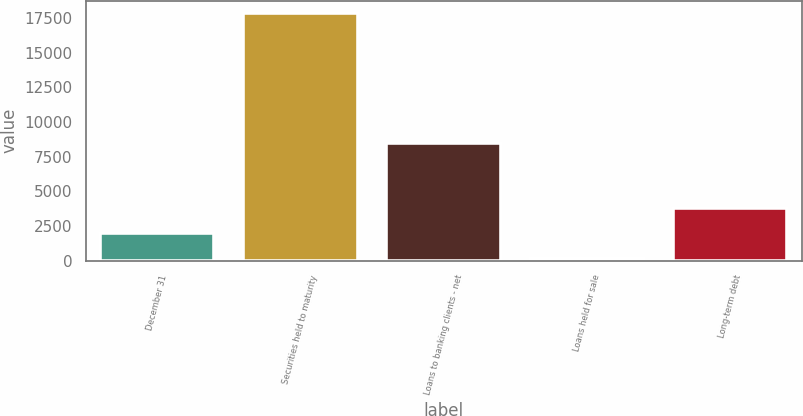Convert chart. <chart><loc_0><loc_0><loc_500><loc_500><bar_chart><fcel>December 31<fcel>Securities held to maturity<fcel>Loans to banking clients - net<fcel>Loans held for sale<fcel>Long-term debt<nl><fcel>2010<fcel>17848<fcel>8469<fcel>194<fcel>3775.4<nl></chart> 